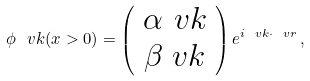<formula> <loc_0><loc_0><loc_500><loc_500>\phi _ { \ } v k ( x > 0 ) = \left ( \begin{array} { c } \alpha _ { \ } v k \\ \beta _ { \ } v k \end{array} \right ) e ^ { i \ v k \cdot \ v r } \, ,</formula> 